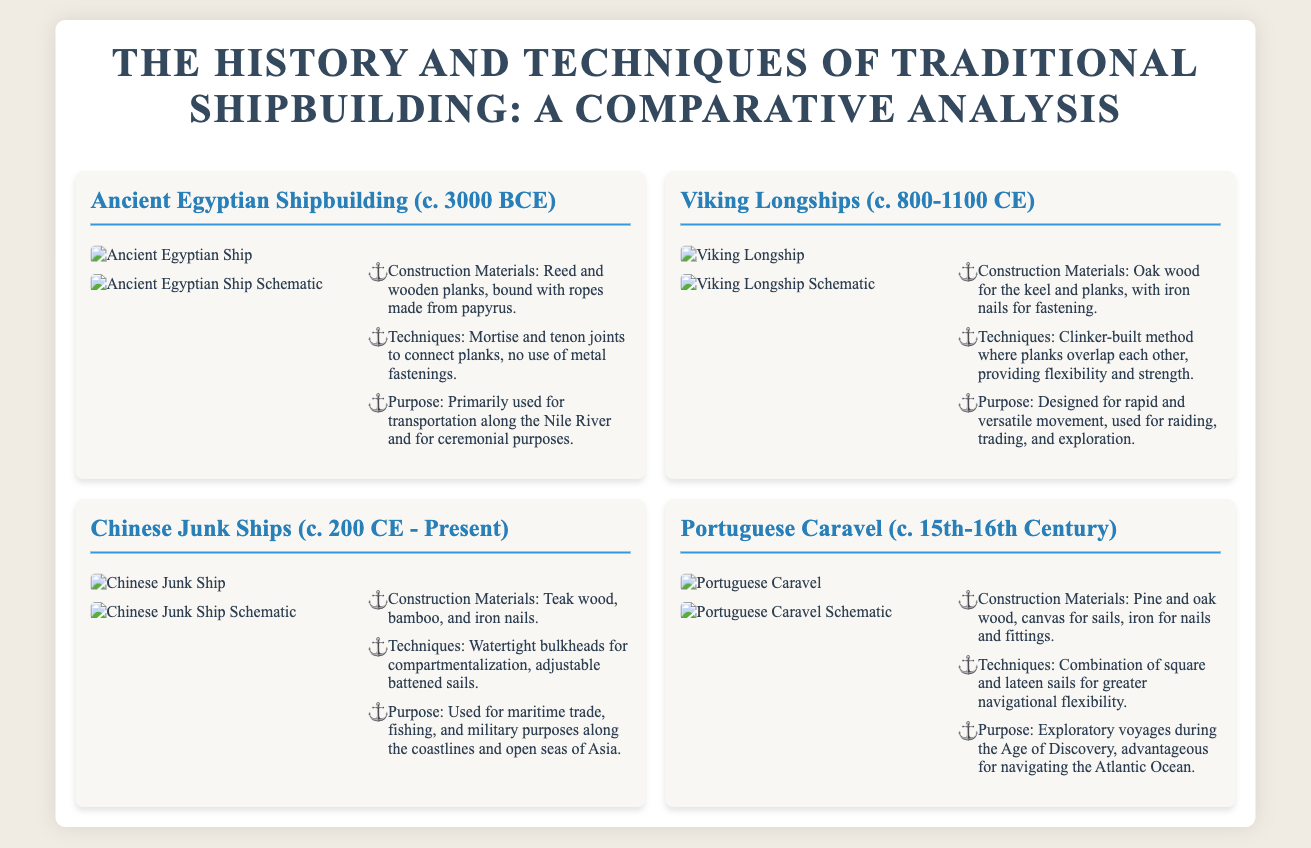What are the construction materials used in Ancient Egyptian Shipbuilding? The document lists reed and wooden planks, bound with ropes made from papyrus as the construction materials.
Answer: Reed and wooden planks What technique was used in Viking Longship construction? The Viking Longships utilized the clinker-built method where planks overlap each other.
Answer: Clinker-built What is the primary purpose of Chinese Junk Ships? The purpose of Chinese Junk Ships includes maritime trade, fishing, and military use along coastlines and open seas.
Answer: Maritime trade, fishing, and military purposes Which ship type was developed during the 15th-16th Century? The document notes that the Portuguese Caravel was developed during the 15th-16th Century.
Answer: Portuguese Caravel What type of wood was primarily used in Viking Longships? The document specifies that oak wood was primarily used for the keel and planks in Viking Longships.
Answer: Oak wood How many ship types are presented in the document? The document contains four distinct ship types presented in it.
Answer: Four What characteristic is notable in the construction of Chinese Junk Ships? The document highlights watertight bulkheads for compartmentalization as a notable characteristic.
Answer: Watertight bulkheads What competitive advantage do Portuguese Caravels provide according to their design? The document states that the combination of square and lateen sails offers greater navigational flexibility.
Answer: Greater navigational flexibility 